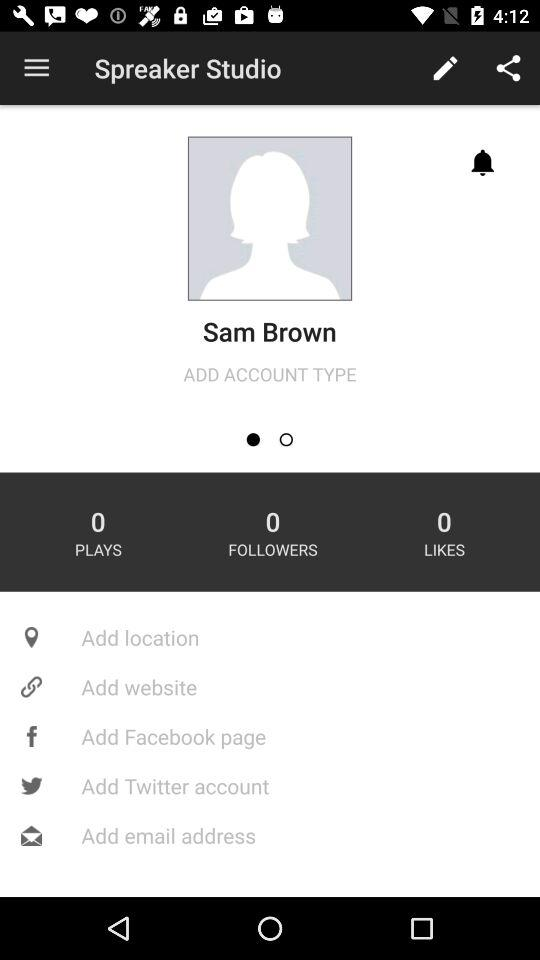How many followers does the person have? The person has 0 followers. 